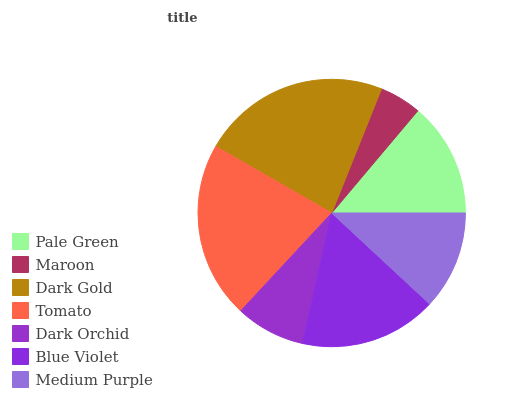Is Maroon the minimum?
Answer yes or no. Yes. Is Dark Gold the maximum?
Answer yes or no. Yes. Is Dark Gold the minimum?
Answer yes or no. No. Is Maroon the maximum?
Answer yes or no. No. Is Dark Gold greater than Maroon?
Answer yes or no. Yes. Is Maroon less than Dark Gold?
Answer yes or no. Yes. Is Maroon greater than Dark Gold?
Answer yes or no. No. Is Dark Gold less than Maroon?
Answer yes or no. No. Is Pale Green the high median?
Answer yes or no. Yes. Is Pale Green the low median?
Answer yes or no. Yes. Is Tomato the high median?
Answer yes or no. No. Is Maroon the low median?
Answer yes or no. No. 